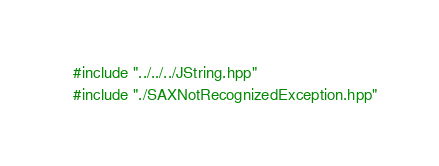Convert code to text. <code><loc_0><loc_0><loc_500><loc_500><_C++_>#include "../../../JString.hpp"
#include "./SAXNotRecognizedException.hpp"
</code> 